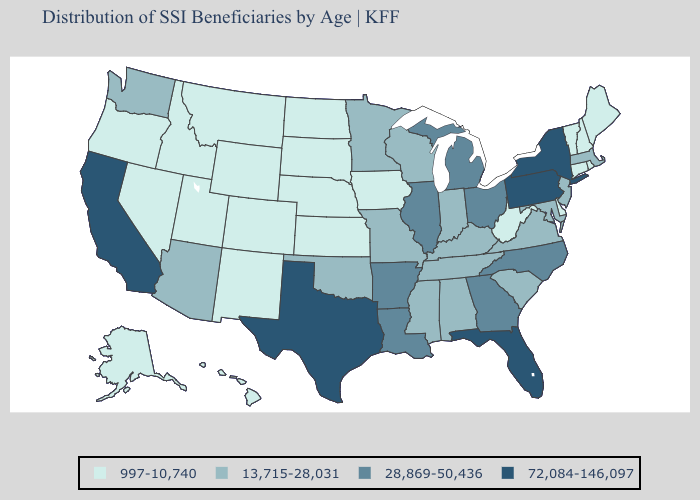Does Oklahoma have the highest value in the South?
Quick response, please. No. What is the highest value in the MidWest ?
Give a very brief answer. 28,869-50,436. Does the first symbol in the legend represent the smallest category?
Give a very brief answer. Yes. Name the states that have a value in the range 13,715-28,031?
Keep it brief. Alabama, Arizona, Indiana, Kentucky, Maryland, Massachusetts, Minnesota, Mississippi, Missouri, New Jersey, Oklahoma, South Carolina, Tennessee, Virginia, Washington, Wisconsin. What is the value of Michigan?
Give a very brief answer. 28,869-50,436. What is the lowest value in the USA?
Concise answer only. 997-10,740. Name the states that have a value in the range 997-10,740?
Answer briefly. Alaska, Colorado, Connecticut, Delaware, Hawaii, Idaho, Iowa, Kansas, Maine, Montana, Nebraska, Nevada, New Hampshire, New Mexico, North Dakota, Oregon, Rhode Island, South Dakota, Utah, Vermont, West Virginia, Wyoming. What is the value of Oklahoma?
Keep it brief. 13,715-28,031. Among the states that border South Dakota , does Minnesota have the lowest value?
Concise answer only. No. Among the states that border Wyoming , which have the lowest value?
Write a very short answer. Colorado, Idaho, Montana, Nebraska, South Dakota, Utah. What is the lowest value in states that border Iowa?
Answer briefly. 997-10,740. Name the states that have a value in the range 13,715-28,031?
Write a very short answer. Alabama, Arizona, Indiana, Kentucky, Maryland, Massachusetts, Minnesota, Mississippi, Missouri, New Jersey, Oklahoma, South Carolina, Tennessee, Virginia, Washington, Wisconsin. What is the value of Montana?
Short answer required. 997-10,740. Among the states that border Georgia , which have the highest value?
Be succinct. Florida. Name the states that have a value in the range 72,084-146,097?
Keep it brief. California, Florida, New York, Pennsylvania, Texas. 